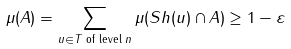Convert formula to latex. <formula><loc_0><loc_0><loc_500><loc_500>\mu ( A ) = \sum _ { u \in T \text { of level } n } \mu ( S h ( u ) \cap A ) \geq 1 - \varepsilon</formula> 